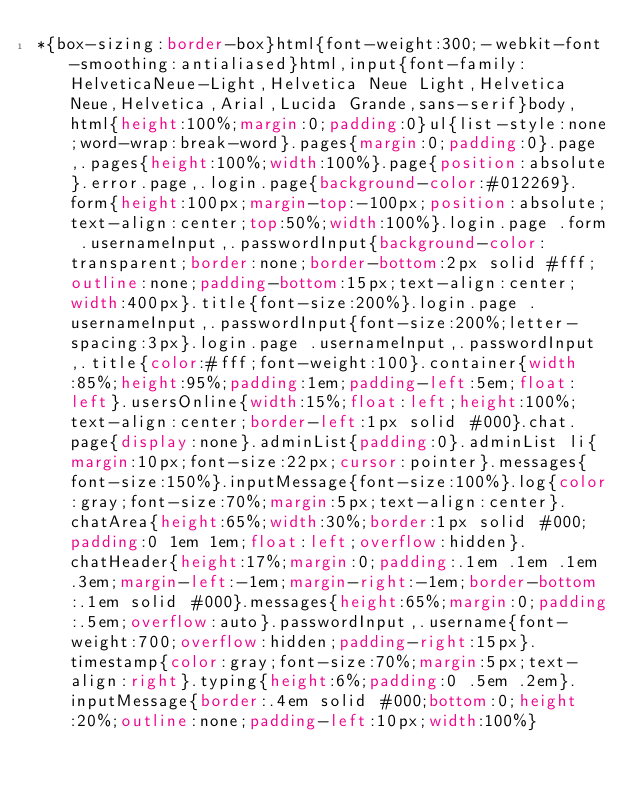<code> <loc_0><loc_0><loc_500><loc_500><_CSS_>*{box-sizing:border-box}html{font-weight:300;-webkit-font-smoothing:antialiased}html,input{font-family:HelveticaNeue-Light,Helvetica Neue Light,Helvetica Neue,Helvetica,Arial,Lucida Grande,sans-serif}body,html{height:100%;margin:0;padding:0}ul{list-style:none;word-wrap:break-word}.pages{margin:0;padding:0}.page,.pages{height:100%;width:100%}.page{position:absolute}.error.page,.login.page{background-color:#012269}.form{height:100px;margin-top:-100px;position:absolute;text-align:center;top:50%;width:100%}.login.page .form .usernameInput,.passwordInput{background-color:transparent;border:none;border-bottom:2px solid #fff;outline:none;padding-bottom:15px;text-align:center;width:400px}.title{font-size:200%}.login.page .usernameInput,.passwordInput{font-size:200%;letter-spacing:3px}.login.page .usernameInput,.passwordInput,.title{color:#fff;font-weight:100}.container{width:85%;height:95%;padding:1em;padding-left:5em;float:left}.usersOnline{width:15%;float:left;height:100%;text-align:center;border-left:1px solid #000}.chat.page{display:none}.adminList{padding:0}.adminList li{margin:10px;font-size:22px;cursor:pointer}.messages{font-size:150%}.inputMessage{font-size:100%}.log{color:gray;font-size:70%;margin:5px;text-align:center}.chatArea{height:65%;width:30%;border:1px solid #000;padding:0 1em 1em;float:left;overflow:hidden}.chatHeader{height:17%;margin:0;padding:.1em .1em .1em .3em;margin-left:-1em;margin-right:-1em;border-bottom:.1em solid #000}.messages{height:65%;margin:0;padding:.5em;overflow:auto}.passwordInput,.username{font-weight:700;overflow:hidden;padding-right:15px}.timestamp{color:gray;font-size:70%;margin:5px;text-align:right}.typing{height:6%;padding:0 .5em .2em}.inputMessage{border:.4em solid #000;bottom:0;height:20%;outline:none;padding-left:10px;width:100%}</code> 